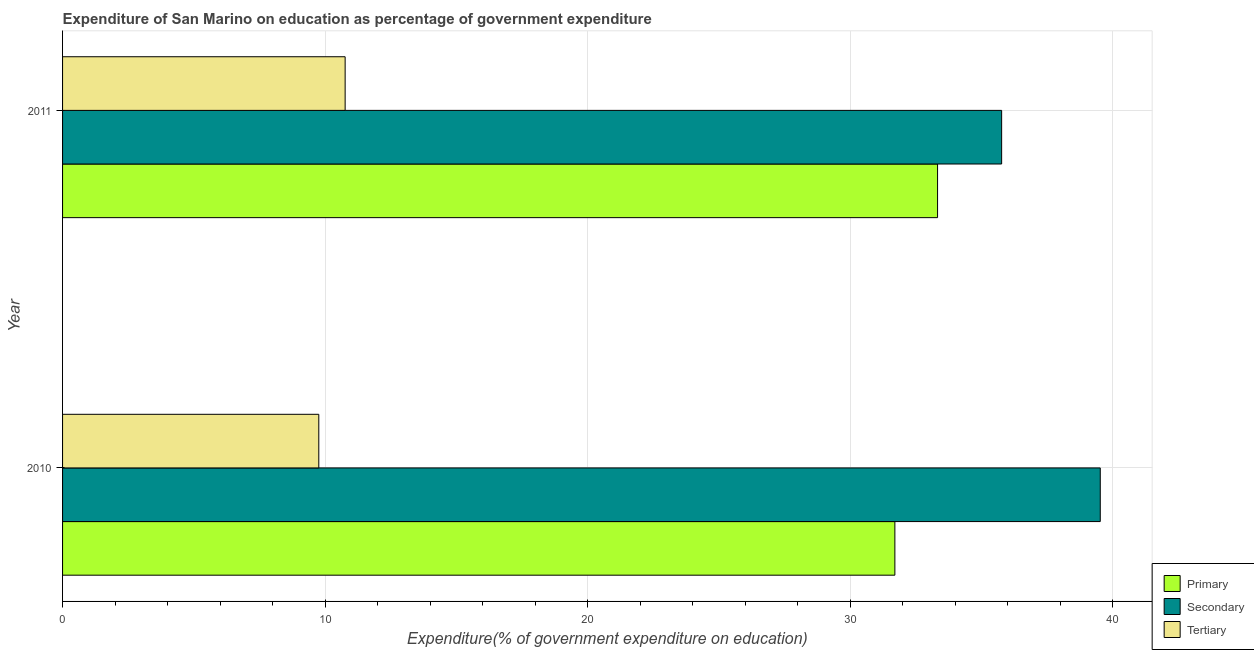How many different coloured bars are there?
Ensure brevity in your answer.  3. How many groups of bars are there?
Your answer should be compact. 2. How many bars are there on the 1st tick from the top?
Make the answer very short. 3. What is the label of the 2nd group of bars from the top?
Your answer should be very brief. 2010. What is the expenditure on secondary education in 2011?
Make the answer very short. 35.76. Across all years, what is the maximum expenditure on primary education?
Offer a very short reply. 33.32. Across all years, what is the minimum expenditure on tertiary education?
Offer a very short reply. 9.76. In which year was the expenditure on tertiary education maximum?
Your answer should be very brief. 2011. What is the total expenditure on secondary education in the graph?
Offer a terse response. 75.28. What is the difference between the expenditure on tertiary education in 2010 and that in 2011?
Your answer should be compact. -1. What is the difference between the expenditure on secondary education in 2011 and the expenditure on tertiary education in 2010?
Offer a very short reply. 26. What is the average expenditure on primary education per year?
Keep it short and to the point. 32.51. In the year 2010, what is the difference between the expenditure on tertiary education and expenditure on primary education?
Make the answer very short. -21.94. What is the ratio of the expenditure on primary education in 2010 to that in 2011?
Offer a very short reply. 0.95. Is the expenditure on tertiary education in 2010 less than that in 2011?
Provide a short and direct response. Yes. In how many years, is the expenditure on primary education greater than the average expenditure on primary education taken over all years?
Give a very brief answer. 1. What does the 3rd bar from the top in 2011 represents?
Your answer should be very brief. Primary. What does the 2nd bar from the bottom in 2011 represents?
Provide a succinct answer. Secondary. Is it the case that in every year, the sum of the expenditure on primary education and expenditure on secondary education is greater than the expenditure on tertiary education?
Offer a terse response. Yes. How many years are there in the graph?
Offer a very short reply. 2. Are the values on the major ticks of X-axis written in scientific E-notation?
Give a very brief answer. No. Does the graph contain any zero values?
Make the answer very short. No. Where does the legend appear in the graph?
Offer a very short reply. Bottom right. What is the title of the graph?
Provide a short and direct response. Expenditure of San Marino on education as percentage of government expenditure. Does "Non-communicable diseases" appear as one of the legend labels in the graph?
Ensure brevity in your answer.  No. What is the label or title of the X-axis?
Provide a short and direct response. Expenditure(% of government expenditure on education). What is the Expenditure(% of government expenditure on education) in Primary in 2010?
Your response must be concise. 31.7. What is the Expenditure(% of government expenditure on education) of Secondary in 2010?
Provide a short and direct response. 39.52. What is the Expenditure(% of government expenditure on education) in Tertiary in 2010?
Keep it short and to the point. 9.76. What is the Expenditure(% of government expenditure on education) in Primary in 2011?
Give a very brief answer. 33.32. What is the Expenditure(% of government expenditure on education) of Secondary in 2011?
Keep it short and to the point. 35.76. What is the Expenditure(% of government expenditure on education) of Tertiary in 2011?
Offer a terse response. 10.76. Across all years, what is the maximum Expenditure(% of government expenditure on education) of Primary?
Keep it short and to the point. 33.32. Across all years, what is the maximum Expenditure(% of government expenditure on education) in Secondary?
Keep it short and to the point. 39.52. Across all years, what is the maximum Expenditure(% of government expenditure on education) in Tertiary?
Offer a terse response. 10.76. Across all years, what is the minimum Expenditure(% of government expenditure on education) in Primary?
Offer a very short reply. 31.7. Across all years, what is the minimum Expenditure(% of government expenditure on education) in Secondary?
Provide a short and direct response. 35.76. Across all years, what is the minimum Expenditure(% of government expenditure on education) of Tertiary?
Offer a very short reply. 9.76. What is the total Expenditure(% of government expenditure on education) in Primary in the graph?
Offer a terse response. 65.02. What is the total Expenditure(% of government expenditure on education) of Secondary in the graph?
Your answer should be very brief. 75.28. What is the total Expenditure(% of government expenditure on education) of Tertiary in the graph?
Give a very brief answer. 20.52. What is the difference between the Expenditure(% of government expenditure on education) of Primary in 2010 and that in 2011?
Offer a terse response. -1.63. What is the difference between the Expenditure(% of government expenditure on education) of Secondary in 2010 and that in 2011?
Offer a very short reply. 3.76. What is the difference between the Expenditure(% of government expenditure on education) of Tertiary in 2010 and that in 2011?
Give a very brief answer. -1. What is the difference between the Expenditure(% of government expenditure on education) of Primary in 2010 and the Expenditure(% of government expenditure on education) of Secondary in 2011?
Give a very brief answer. -4.07. What is the difference between the Expenditure(% of government expenditure on education) of Primary in 2010 and the Expenditure(% of government expenditure on education) of Tertiary in 2011?
Make the answer very short. 20.93. What is the difference between the Expenditure(% of government expenditure on education) in Secondary in 2010 and the Expenditure(% of government expenditure on education) in Tertiary in 2011?
Provide a succinct answer. 28.76. What is the average Expenditure(% of government expenditure on education) in Primary per year?
Your answer should be very brief. 32.51. What is the average Expenditure(% of government expenditure on education) of Secondary per year?
Your answer should be very brief. 37.64. What is the average Expenditure(% of government expenditure on education) in Tertiary per year?
Your answer should be compact. 10.26. In the year 2010, what is the difference between the Expenditure(% of government expenditure on education) in Primary and Expenditure(% of government expenditure on education) in Secondary?
Offer a very short reply. -7.82. In the year 2010, what is the difference between the Expenditure(% of government expenditure on education) in Primary and Expenditure(% of government expenditure on education) in Tertiary?
Your response must be concise. 21.94. In the year 2010, what is the difference between the Expenditure(% of government expenditure on education) in Secondary and Expenditure(% of government expenditure on education) in Tertiary?
Offer a terse response. 29.76. In the year 2011, what is the difference between the Expenditure(% of government expenditure on education) of Primary and Expenditure(% of government expenditure on education) of Secondary?
Provide a succinct answer. -2.44. In the year 2011, what is the difference between the Expenditure(% of government expenditure on education) of Primary and Expenditure(% of government expenditure on education) of Tertiary?
Provide a short and direct response. 22.56. In the year 2011, what is the difference between the Expenditure(% of government expenditure on education) of Secondary and Expenditure(% of government expenditure on education) of Tertiary?
Your answer should be compact. 25. What is the ratio of the Expenditure(% of government expenditure on education) of Primary in 2010 to that in 2011?
Keep it short and to the point. 0.95. What is the ratio of the Expenditure(% of government expenditure on education) of Secondary in 2010 to that in 2011?
Your response must be concise. 1.1. What is the ratio of the Expenditure(% of government expenditure on education) of Tertiary in 2010 to that in 2011?
Make the answer very short. 0.91. What is the difference between the highest and the second highest Expenditure(% of government expenditure on education) of Primary?
Offer a very short reply. 1.63. What is the difference between the highest and the second highest Expenditure(% of government expenditure on education) of Secondary?
Your response must be concise. 3.76. What is the difference between the highest and the lowest Expenditure(% of government expenditure on education) in Primary?
Provide a succinct answer. 1.63. What is the difference between the highest and the lowest Expenditure(% of government expenditure on education) in Secondary?
Provide a succinct answer. 3.76. 